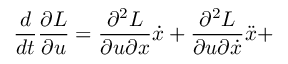Convert formula to latex. <formula><loc_0><loc_0><loc_500><loc_500>\frac { d } { d t } \frac { \partial L } { \partial u } = \frac { \partial ^ { 2 } L } { \partial u \partial x } \dot { x } + \frac { \partial ^ { 2 } L } { \partial u \partial \dot { x } } \ddot { x } +</formula> 